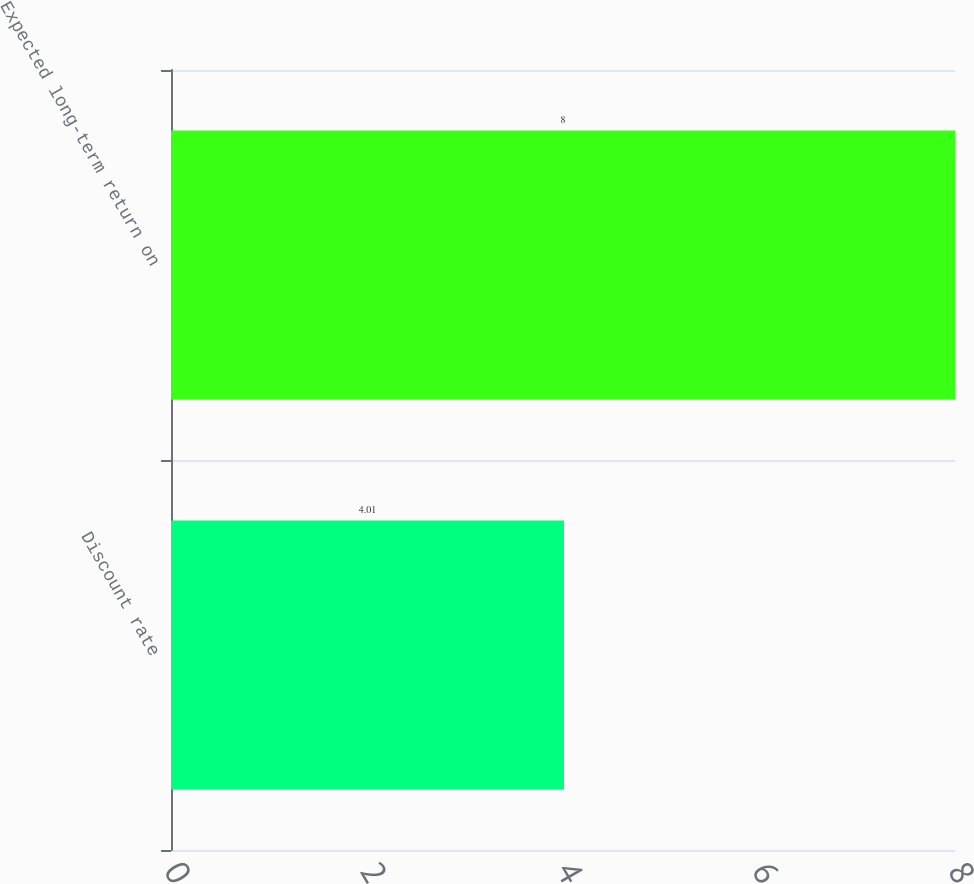Convert chart. <chart><loc_0><loc_0><loc_500><loc_500><bar_chart><fcel>Discount rate<fcel>Expected long-term return on<nl><fcel>4.01<fcel>8<nl></chart> 